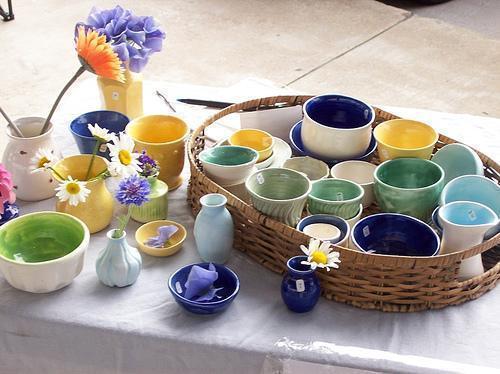How many of the vases are made from something other than glass?
Answer the question by selecting the correct answer among the 4 following choices.
Options: Five, four, one, two. Two. 